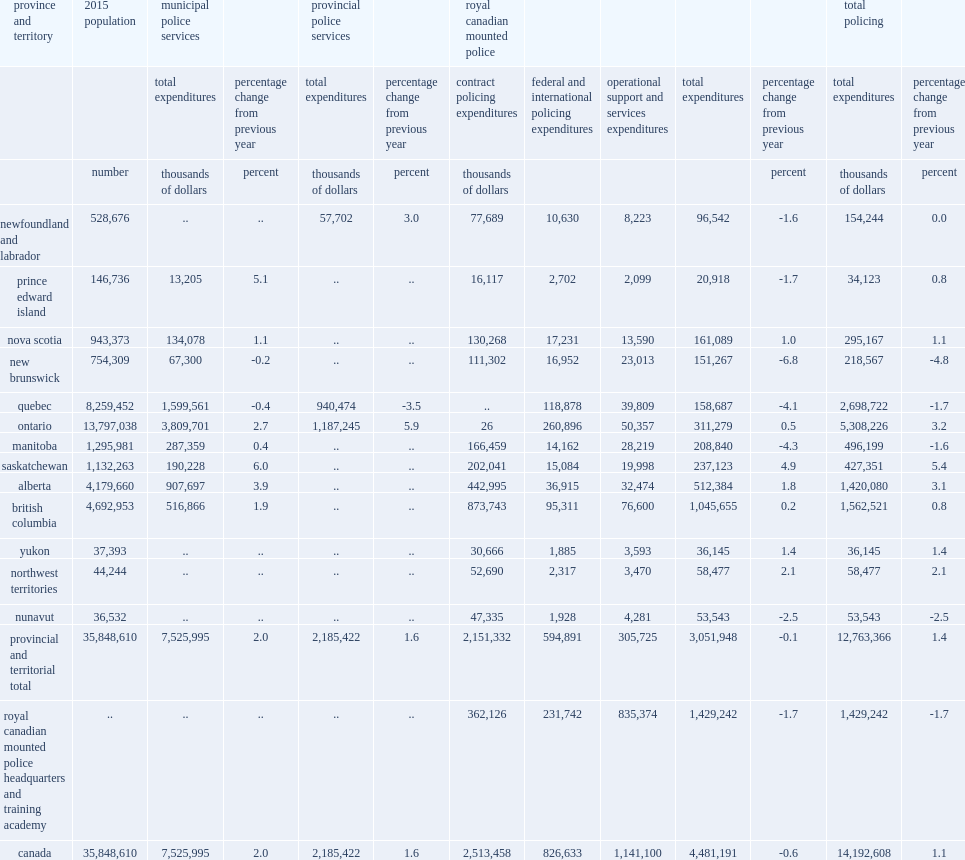Can you give me this table as a dict? {'header': ['province and territory', '2015 population', 'municipal police services', '', 'provincial police services', '', 'royal canadian mounted police', '', '', '', '', 'total policing', ''], 'rows': [['', '', 'total expenditures', 'percentage change from previous year', 'total expenditures', 'percentage change from previous year', 'contract policing expenditures', 'federal and international policing expenditures', 'operational support and services expenditures', 'total expenditures', 'percentage change from previous year', 'total expenditures', 'percentage change from previous year'], ['', 'number', 'thousands of dollars', 'percent', 'thousands of dollars', 'percent', 'thousands of dollars', '', '', '', 'percent', 'thousands of dollars', 'percent'], ['newfoundland and labrador', '528,676', '..', '..', '57,702', '3.0', '77,689', '10,630', '8,223', '96,542', '-1.6', '154,244', '0.0'], ['prince edward island', '146,736', '13,205', '5.1', '..', '..', '16,117', '2,702', '2,099', '20,918', '-1.7', '34,123', '0.8'], ['nova scotia', '943,373', '134,078', '1.1', '..', '..', '130,268', '17,231', '13,590', '161,089', '1.0', '295,167', '1.1'], ['new brunswick', '754,309', '67,300', '-0.2', '..', '..', '111,302', '16,952', '23,013', '151,267', '-6.8', '218,567', '-4.8'], ['quebec', '8,259,452', '1,599,561', '-0.4', '940,474', '-3.5', '..', '118,878', '39,809', '158,687', '-4.1', '2,698,722', '-1.7'], ['ontario', '13,797,038', '3,809,701', '2.7', '1,187,245', '5.9', '26', '260,896', '50,357', '311,279', '0.5', '5,308,226', '3.2'], ['manitoba', '1,295,981', '287,359', '0.4', '..', '..', '166,459', '14,162', '28,219', '208,840', '-4.3', '496,199', '-1.6'], ['saskatchewan', '1,132,263', '190,228', '6.0', '..', '..', '202,041', '15,084', '19,998', '237,123', '4.9', '427,351', '5.4'], ['alberta', '4,179,660', '907,697', '3.9', '..', '..', '442,995', '36,915', '32,474', '512,384', '1.8', '1,420,080', '3.1'], ['british columbia', '4,692,953', '516,866', '1.9', '..', '..', '873,743', '95,311', '76,600', '1,045,655', '0.2', '1,562,521', '0.8'], ['yukon', '37,393', '..', '..', '..', '..', '30,666', '1,885', '3,593', '36,145', '1.4', '36,145', '1.4'], ['northwest territories', '44,244', '..', '..', '..', '..', '52,690', '2,317', '3,470', '58,477', '2.1', '58,477', '2.1'], ['nunavut', '36,532', '..', '..', '..', '..', '47,335', '1,928', '4,281', '53,543', '-2.5', '53,543', '-2.5'], ['provincial and territorial total', '35,848,610', '7,525,995', '2.0', '2,185,422', '1.6', '2,151,332', '594,891', '305,725', '3,051,948', '-0.1', '12,763,366', '1.4'], ['royal canadian mounted police headquarters and training academy', '..', '..', '..', '..', '..', '362,126', '231,742', '835,374', '1,429,242', '-1.7', '1,429,242', '-1.7'], ['canada', '35,848,610', '7,525,995', '2.0', '2,185,422', '1.6', '2,513,458', '826,633', '1,141,100', '4,481,191', '-0.6', '14,192,608', '1.1']]} Total operating expenditures for all police services across canada in 2015/2016 amounted to $14.2 billion in current dollars. 14192608.0. What is the percentage of contract policing expenditures in the total rcmp expenditures? 0.560891. What is the percentage of perational support and services expenditures in the total rcmp expenditures? 0.254642. What is the percentage of federal and international policing expenditures in the total rcmp expenditures? 0.184467. With $4.5 billion reported in 2015/2016, what is the percentage of the rcmp accounted for total police operating expenditures in the country? 0.315741. What is the percentage of the total operating expenditures for the rcmp decreased from the previous year? 0.6. 